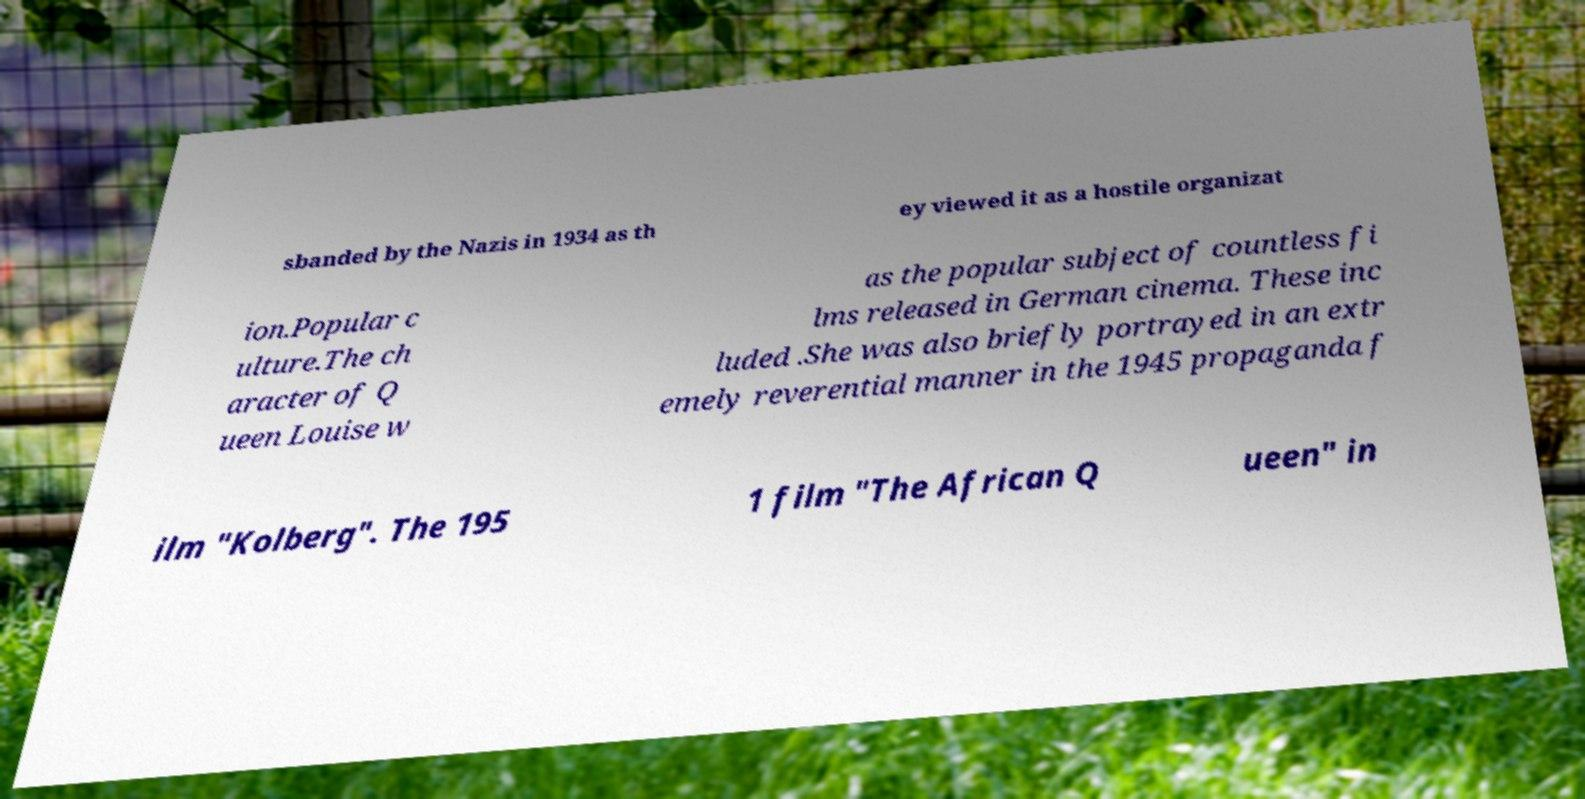Can you accurately transcribe the text from the provided image for me? sbanded by the Nazis in 1934 as th ey viewed it as a hostile organizat ion.Popular c ulture.The ch aracter of Q ueen Louise w as the popular subject of countless fi lms released in German cinema. These inc luded .She was also briefly portrayed in an extr emely reverential manner in the 1945 propaganda f ilm "Kolberg". The 195 1 film "The African Q ueen" in 